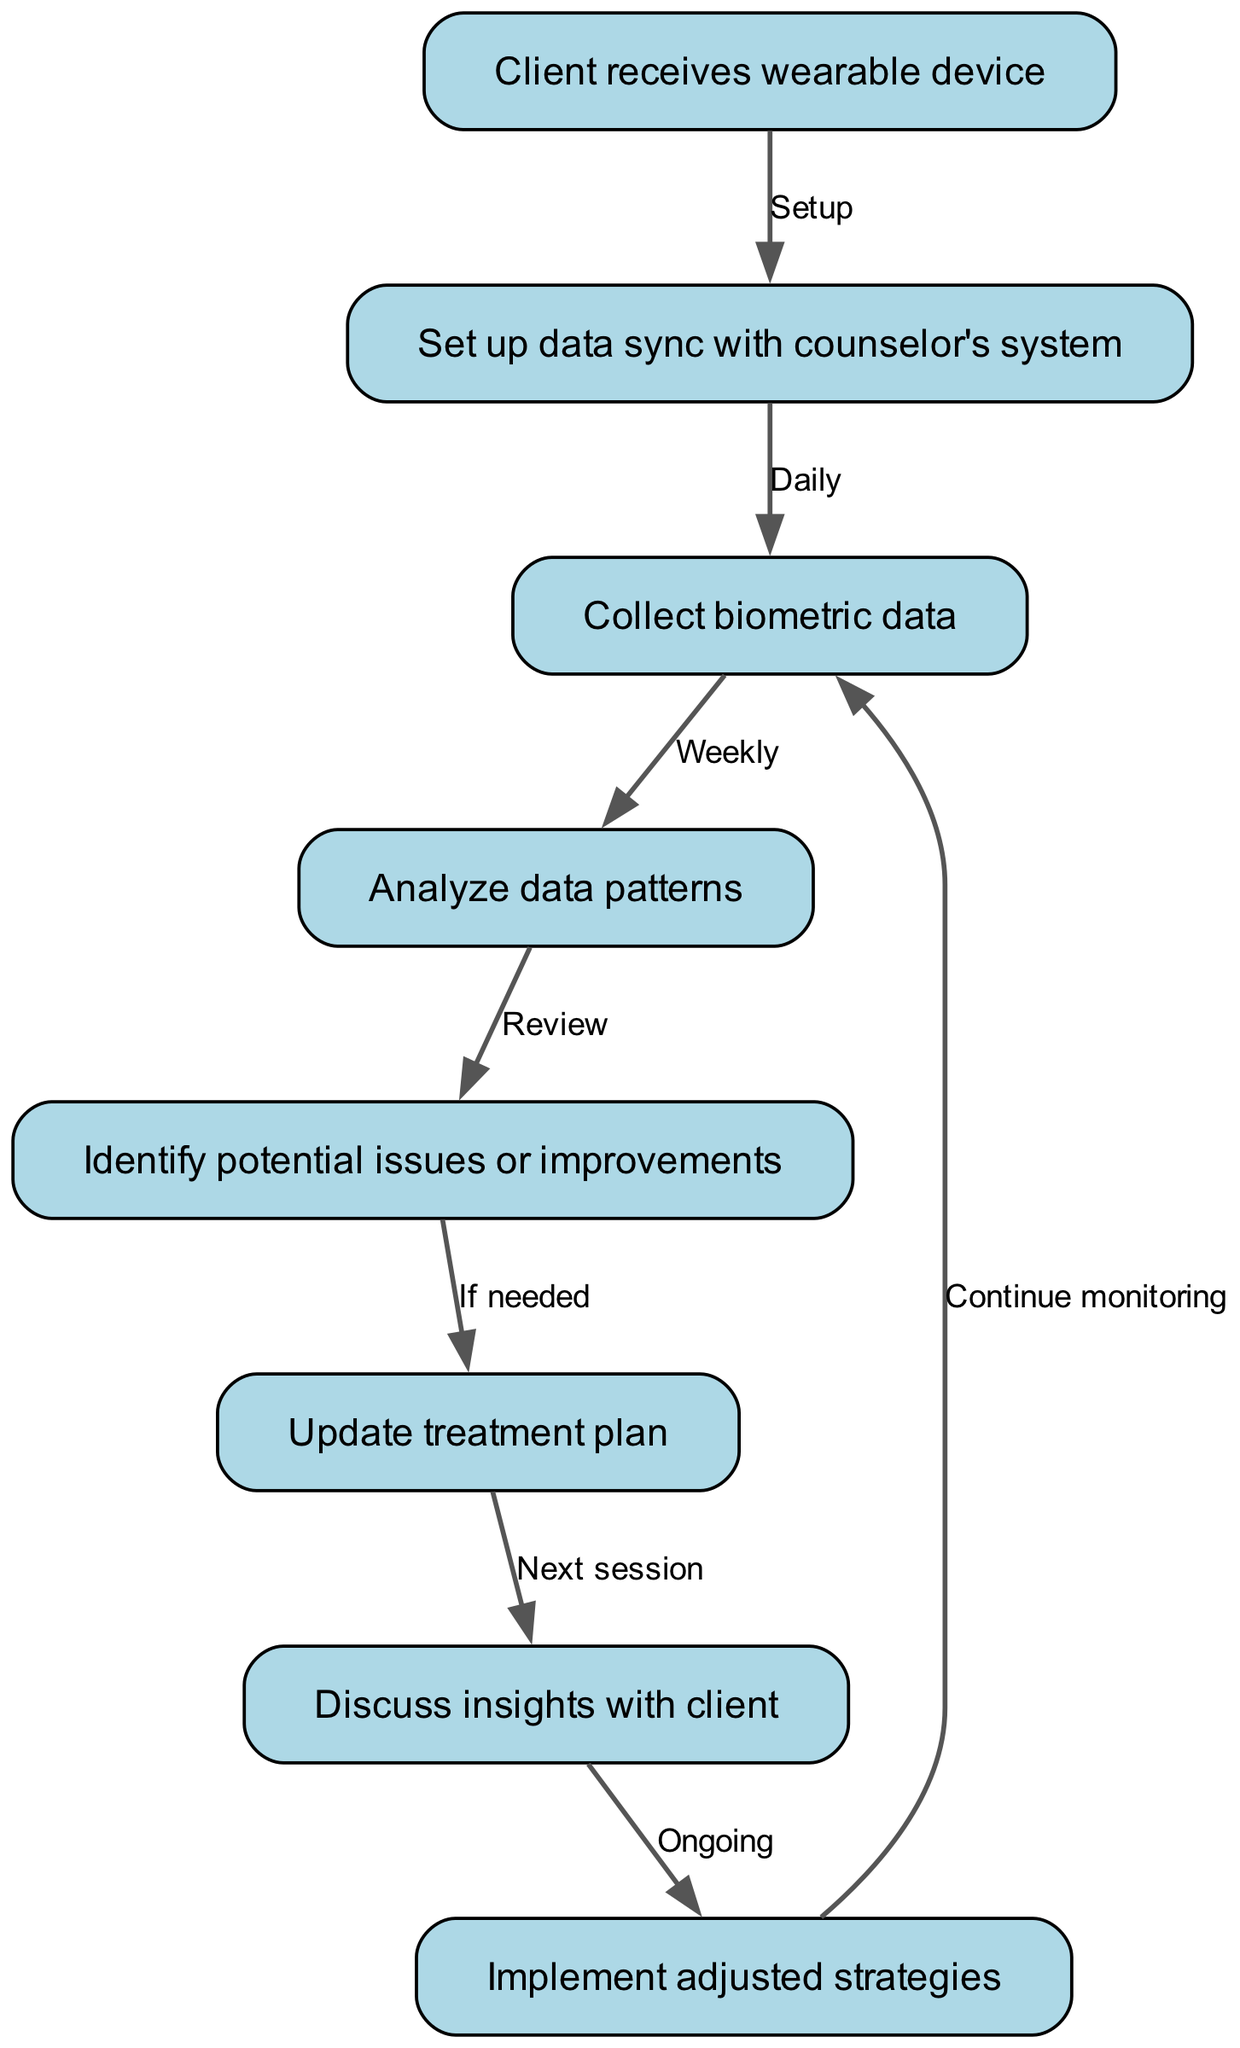What is the first step in the workflow? The first node in the workflow represents the initial action where the client receives the wearable device, which is identified as step 1.
Answer: Client receives wearable device How many nodes are present in the diagram? By counting the distinct steps or actions described in the nodes section, there are 8 unique nodes indicated, thus the total count is 8.
Answer: 8 What happens after the data is set up to sync with the counselor's system? The workflow indicates that after the data sync setup, the next step involves the collection of biometric data from the wearable device, as shown by the arrow leading to step 3.
Answer: Collect biometric data At which step are potential issues or improvements identified? According to the flow, potential issues or improvements are identified at step 5, which follows the data analysis conducted in step 4.
Answer: Identify potential issues or improvements What is the relationship between updating the treatment plan and discussing insights with the client? The update to the treatment plan, occurring at step 6, directly precedes the discussion of insights with the client in step 7, creating a sequential relationship between these two actions.
Answer: Next session How frequently is biometric data collected according to the diagram? The diagram notes that data collection occurs daily, which establishes the rhythm of how often the biometric readings are gathered from the wearable device.
Answer: Daily What is the last action taken in the workflow? The final action noted in the flow chart is to continue monitoring biometric data, which loops back to the data collection step, suggesting an ongoing process.
Answer: Continue monitoring What triggers an update to the treatment plan? The need to update the treatment plan is triggered by the identification of potential issues or improvements during the data analysis and review process as indicated in steps 4 and 5.
Answer: If needed What kind of tool is being integrated into the client treatment plans? The workflow centers around the integration of a wearable device, classified as a tool for collecting biometric data relevant to the client's treatment.
Answer: Wearable device 